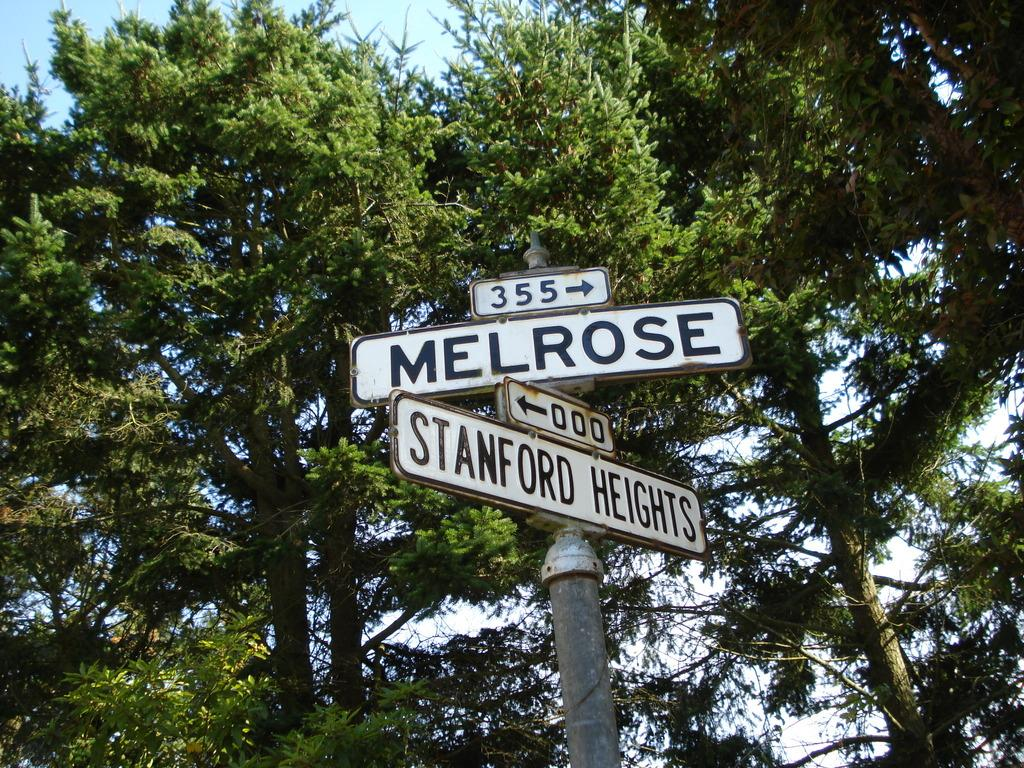What type of signs are present in the image? There are direction boards and name boards in the image. What else can be seen in the image besides the signs? There are trees in the image. What is visible in the background of the image? The sky is visible in the background of the image. Can you see the moon in the image? No, the moon is not visible in the image; only the sky is visible in the background. Is there a lift present in the image? No, there is no lift present in the image. 